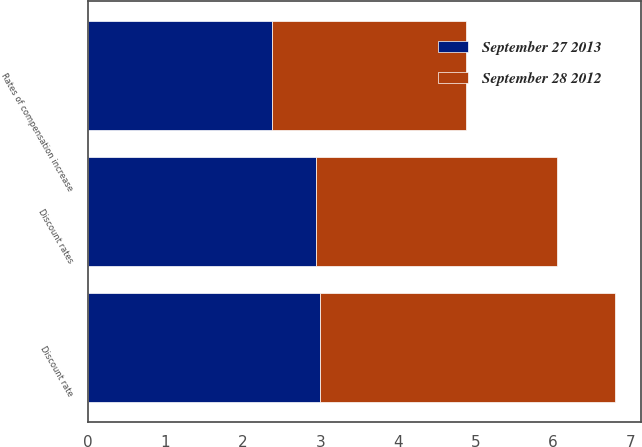<chart> <loc_0><loc_0><loc_500><loc_500><stacked_bar_chart><ecel><fcel>Discount rates<fcel>Rates of compensation increase<fcel>Discount rate<nl><fcel>September 28 2012<fcel>3.11<fcel>2.51<fcel>3.8<nl><fcel>September 27 2013<fcel>2.94<fcel>2.37<fcel>3<nl></chart> 